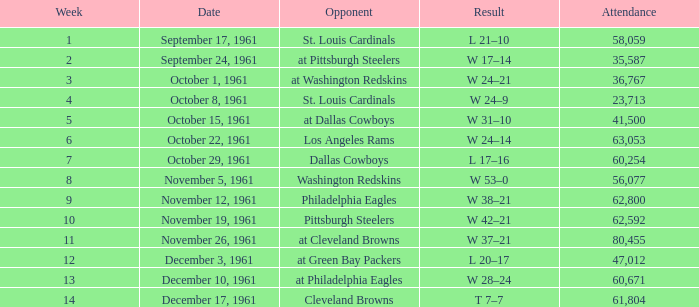Which Week has an Opponent of washington redskins, and an Attendance larger than 56,077? 0.0. 